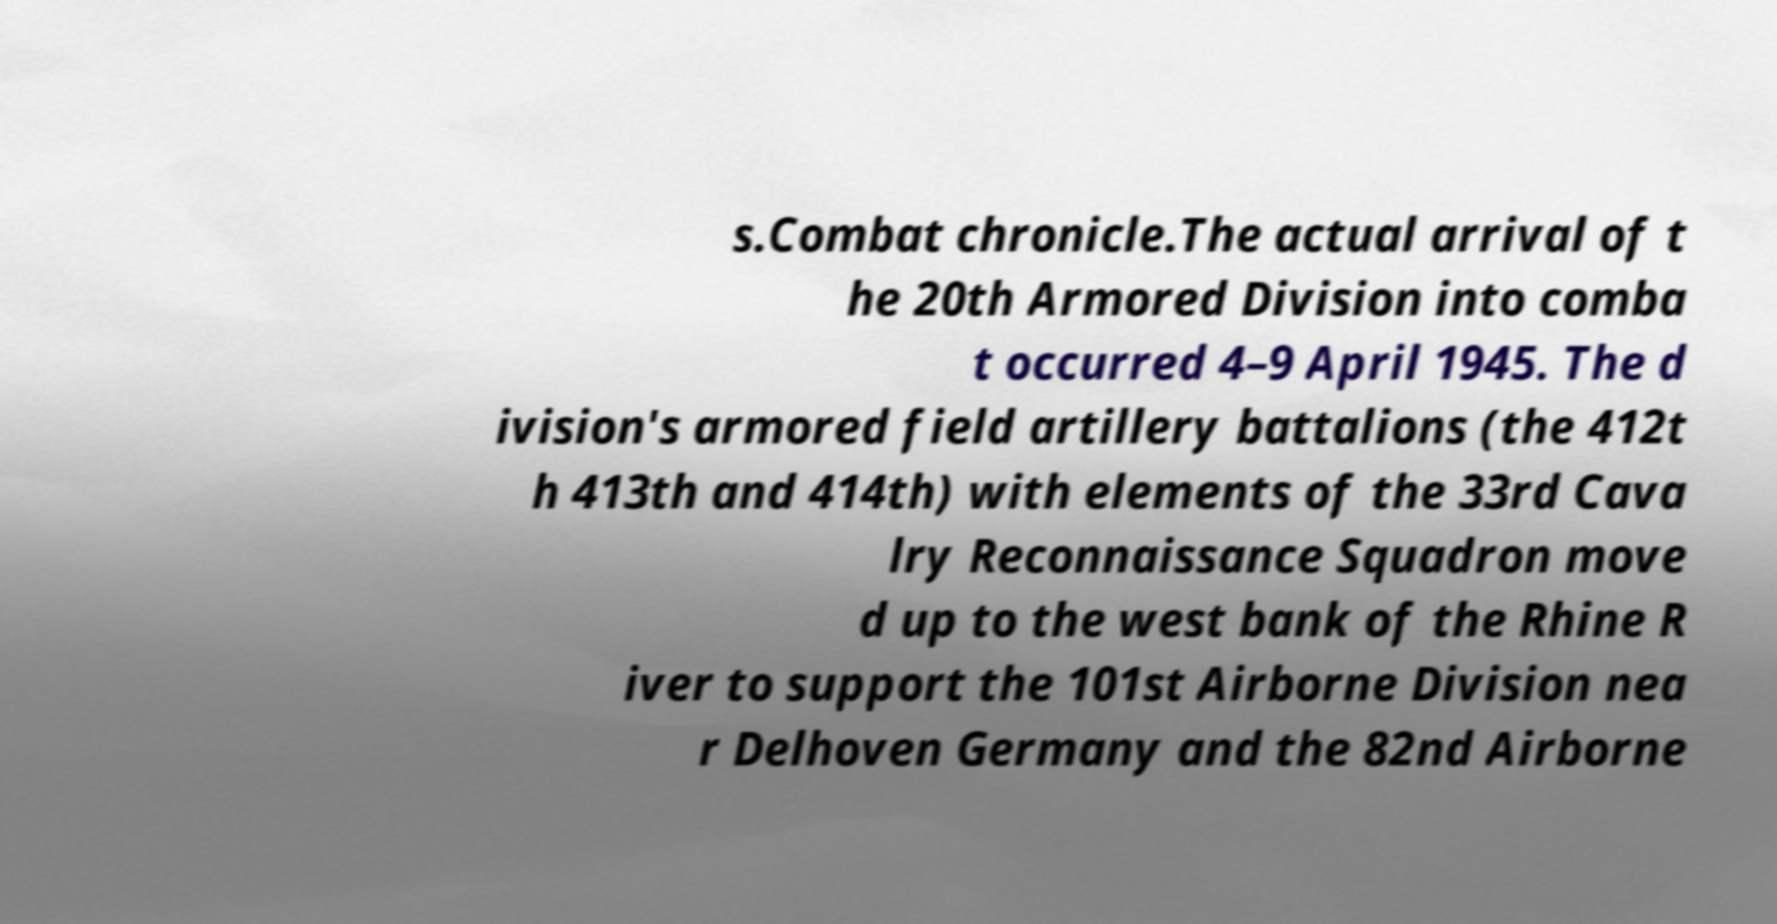What messages or text are displayed in this image? I need them in a readable, typed format. s.Combat chronicle.The actual arrival of t he 20th Armored Division into comba t occurred 4–9 April 1945. The d ivision's armored field artillery battalions (the 412t h 413th and 414th) with elements of the 33rd Cava lry Reconnaissance Squadron move d up to the west bank of the Rhine R iver to support the 101st Airborne Division nea r Delhoven Germany and the 82nd Airborne 